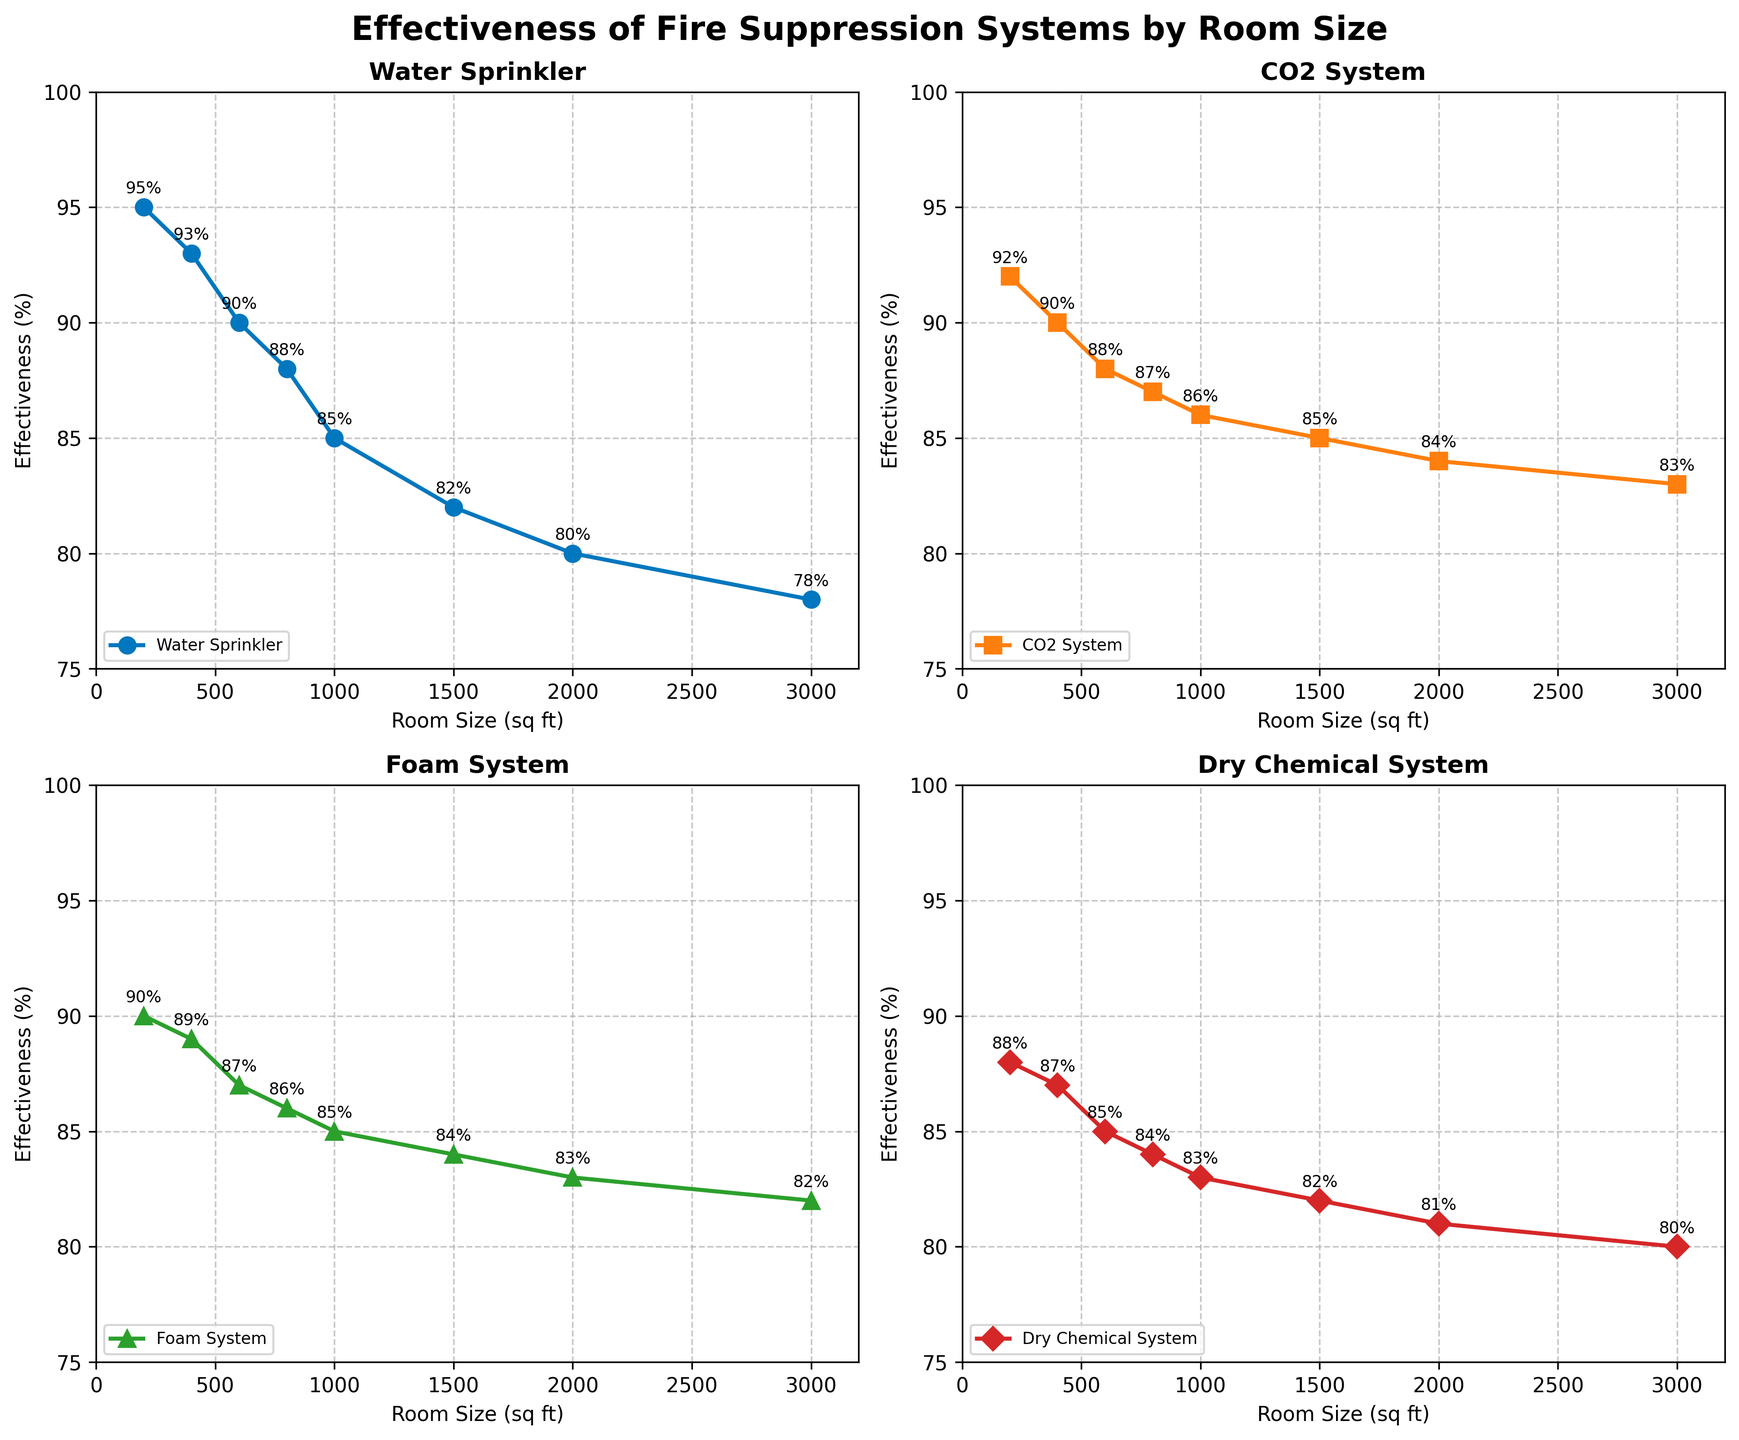What is the title of the figure? The title is the large, bold text at the top of the figure that summarizes what the figure represents.
Answer: Effectiveness of Fire Suppression Systems by Room Size What is the effectiveness of the CO2 system in a 600 sq ft room? Look at the subplot titled "CO2 System" and find the data point where the x-axis (Room Size) is 600 sq ft. The y-axis gives the corresponding effectiveness.
Answer: 88% Which fire suppression system has the highest effectiveness in a 200 sq ft room? For each subplot, find the data point where the x-axis is 200 sq ft and compare the y-axis values.
Answer: Water Sprinkler How does the effectiveness of the Dry Chemical System change as room size increases from 200 sq ft to 2000 sq ft? Look at the "Dry Chemical System" subplot and compare the y-axis values at 200 sq ft and 2000 sq ft.
Answer: Decreases Which system shows the least drop in effectiveness as room size increases from 200 sq ft to 3000 sq ft? Calculate the difference in effectiveness at 200 sq ft and 3000 sq ft for each system and compare the drops. Water Sprinkler: 95% - 78% = 17%, CO2 System: 92% - 83% = 9%, Foam System: 90% - 82% = 8%, Dry Chemical System: 88% - 80% = 8%. The smallest drop is 8% for both Foam and Dry Chemical Systems.
Answer: Foam System and Dry Chemical System What is the average effectiveness of the Water Sprinkler system for rooms up to 1000 sq ft? Consider the effectiveness values of Water Sprinkler at 200, 400, 600, 800, and 1000 sq ft (95%, 93%, 90%, 88%, and 85%). Calculate their average. (95 + 93 + 90 + 88 + 85) / 5 = 90.2%
Answer: 90.2% Which system has the highest effectiveness in a 1500 sq ft room? Check the y-axis values for each system when the x-axis is 1500 sq ft. The highest effectiveness value represents the system with the highest effectiveness.
Answer: CO2 System Between which room sizes does the Foam System show the least change in effectiveness? Compare the effectiveness values for adjacent room sizes in the "Foam System" subplot and identify the pair with the smallest difference. The smallest change is between 800 sq ft and 1000 sq ft (1%).
Answer: 800 sq ft and 1000 sq ft What is the trend of effectiveness for the CO2 System as room size increases? Observe the direction of the data points in the "CO2 System" subplot as the room size increases along the x-axis. The general trend is a decrease.
Answer: Decreasing 